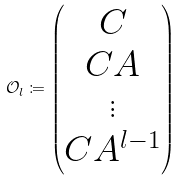Convert formula to latex. <formula><loc_0><loc_0><loc_500><loc_500>\mathcal { O } _ { l } \coloneqq \begin{pmatrix} C \\ C A \\ \vdots \\ C A ^ { l - 1 } \end{pmatrix}</formula> 